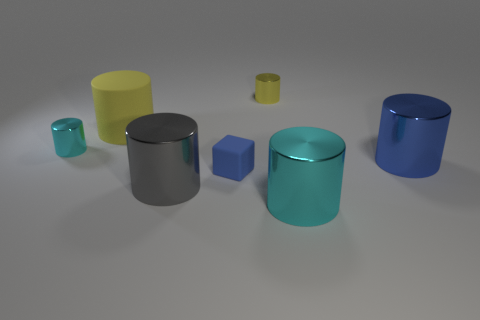Subtract all yellow cylinders. How many cylinders are left? 4 Subtract all tiny cylinders. How many cylinders are left? 4 Add 1 big cylinders. How many objects exist? 8 Subtract all green cylinders. Subtract all gray cubes. How many cylinders are left? 6 Subtract all tiny yellow metallic cylinders. Subtract all rubber objects. How many objects are left? 4 Add 7 tiny cyan cylinders. How many tiny cyan cylinders are left? 8 Add 2 blue cylinders. How many blue cylinders exist? 3 Subtract 0 yellow spheres. How many objects are left? 7 Subtract all cubes. How many objects are left? 6 